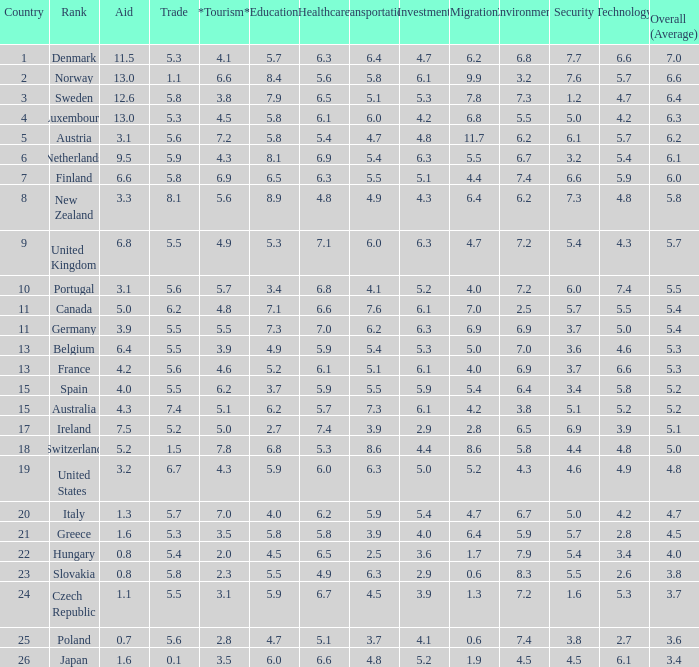What is the migration rating when trade is 5.7? 4.7. 